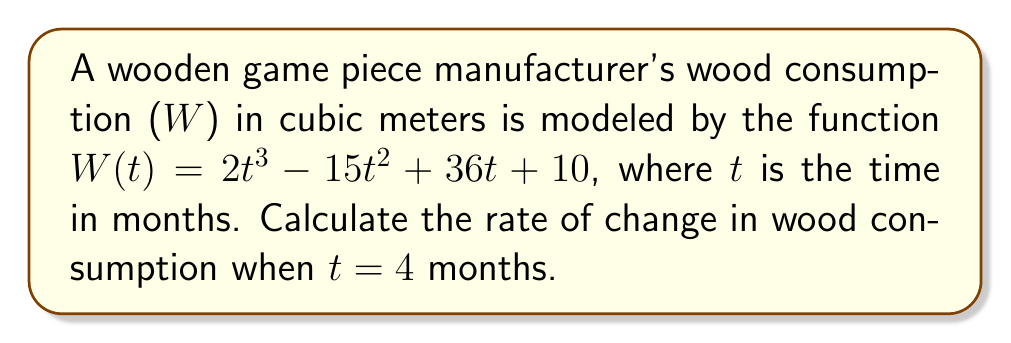Provide a solution to this math problem. To find the rate of change in wood consumption, we need to calculate the derivative of the given function and evaluate it at t = 4.

Step 1: Find the derivative of W(t)
$$\frac{dW}{dt} = \frac{d}{dt}(2t^3 - 15t^2 + 36t + 10)$$
$$\frac{dW}{dt} = 6t^2 - 30t + 36$$

Step 2: Evaluate the derivative at t = 4
$$\frac{dW}{dt}\bigg|_{t=4} = 6(4)^2 - 30(4) + 36$$
$$= 6(16) - 120 + 36$$
$$= 96 - 120 + 36$$
$$= 12$$

The rate of change in wood consumption when t = 4 months is 12 cubic meters per month.
Answer: 12 cubic meters per month 